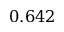<formula> <loc_0><loc_0><loc_500><loc_500>0 . 6 4 2</formula> 